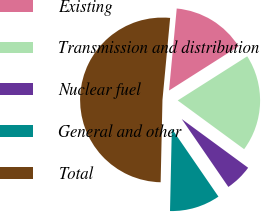<chart> <loc_0><loc_0><loc_500><loc_500><pie_chart><fcel>Existing<fcel>Transmission and distribution<fcel>Nuclear fuel<fcel>General and other<fcel>Total<nl><fcel>14.51%<fcel>19.08%<fcel>5.35%<fcel>9.93%<fcel>51.14%<nl></chart> 